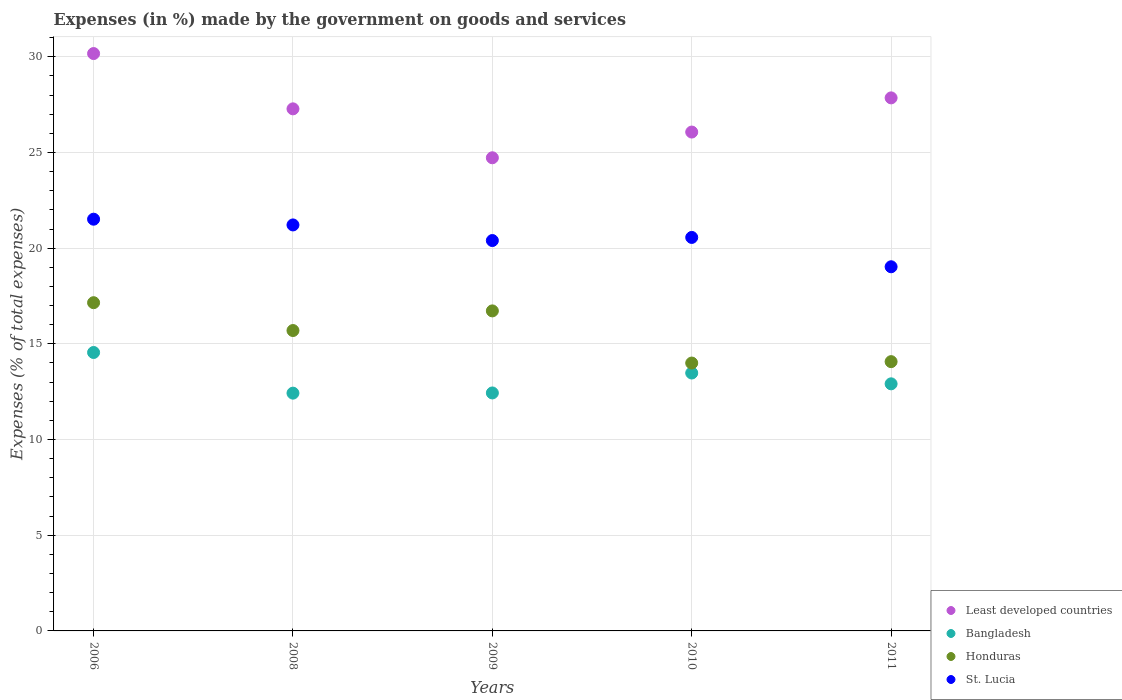What is the percentage of expenses made by the government on goods and services in Honduras in 2010?
Provide a succinct answer. 14. Across all years, what is the maximum percentage of expenses made by the government on goods and services in St. Lucia?
Ensure brevity in your answer.  21.51. Across all years, what is the minimum percentage of expenses made by the government on goods and services in Honduras?
Offer a terse response. 14. In which year was the percentage of expenses made by the government on goods and services in Honduras maximum?
Ensure brevity in your answer.  2006. What is the total percentage of expenses made by the government on goods and services in Least developed countries in the graph?
Your answer should be very brief. 136.1. What is the difference between the percentage of expenses made by the government on goods and services in Bangladesh in 2006 and that in 2011?
Offer a very short reply. 1.64. What is the difference between the percentage of expenses made by the government on goods and services in St. Lucia in 2006 and the percentage of expenses made by the government on goods and services in Least developed countries in 2010?
Offer a terse response. -4.55. What is the average percentage of expenses made by the government on goods and services in St. Lucia per year?
Your response must be concise. 20.54. In the year 2011, what is the difference between the percentage of expenses made by the government on goods and services in Honduras and percentage of expenses made by the government on goods and services in St. Lucia?
Give a very brief answer. -4.96. What is the ratio of the percentage of expenses made by the government on goods and services in Least developed countries in 2009 to that in 2010?
Your response must be concise. 0.95. Is the percentage of expenses made by the government on goods and services in Honduras in 2008 less than that in 2009?
Offer a terse response. Yes. Is the difference between the percentage of expenses made by the government on goods and services in Honduras in 2009 and 2010 greater than the difference between the percentage of expenses made by the government on goods and services in St. Lucia in 2009 and 2010?
Give a very brief answer. Yes. What is the difference between the highest and the second highest percentage of expenses made by the government on goods and services in Bangladesh?
Offer a terse response. 1.07. What is the difference between the highest and the lowest percentage of expenses made by the government on goods and services in Honduras?
Give a very brief answer. 3.15. Is the sum of the percentage of expenses made by the government on goods and services in Honduras in 2009 and 2010 greater than the maximum percentage of expenses made by the government on goods and services in Bangladesh across all years?
Give a very brief answer. Yes. Does the percentage of expenses made by the government on goods and services in Least developed countries monotonically increase over the years?
Provide a succinct answer. No. How many years are there in the graph?
Give a very brief answer. 5. Are the values on the major ticks of Y-axis written in scientific E-notation?
Provide a succinct answer. No. How many legend labels are there?
Give a very brief answer. 4. What is the title of the graph?
Your response must be concise. Expenses (in %) made by the government on goods and services. What is the label or title of the X-axis?
Your answer should be compact. Years. What is the label or title of the Y-axis?
Offer a very short reply. Expenses (% of total expenses). What is the Expenses (% of total expenses) in Least developed countries in 2006?
Your response must be concise. 30.17. What is the Expenses (% of total expenses) of Bangladesh in 2006?
Ensure brevity in your answer.  14.55. What is the Expenses (% of total expenses) in Honduras in 2006?
Your response must be concise. 17.15. What is the Expenses (% of total expenses) of St. Lucia in 2006?
Provide a succinct answer. 21.51. What is the Expenses (% of total expenses) of Least developed countries in 2008?
Your answer should be very brief. 27.28. What is the Expenses (% of total expenses) in Bangladesh in 2008?
Keep it short and to the point. 12.42. What is the Expenses (% of total expenses) in Honduras in 2008?
Provide a succinct answer. 15.7. What is the Expenses (% of total expenses) in St. Lucia in 2008?
Keep it short and to the point. 21.21. What is the Expenses (% of total expenses) of Least developed countries in 2009?
Ensure brevity in your answer.  24.72. What is the Expenses (% of total expenses) in Bangladesh in 2009?
Ensure brevity in your answer.  12.44. What is the Expenses (% of total expenses) in Honduras in 2009?
Make the answer very short. 16.72. What is the Expenses (% of total expenses) in St. Lucia in 2009?
Keep it short and to the point. 20.4. What is the Expenses (% of total expenses) of Least developed countries in 2010?
Make the answer very short. 26.07. What is the Expenses (% of total expenses) of Bangladesh in 2010?
Give a very brief answer. 13.48. What is the Expenses (% of total expenses) in Honduras in 2010?
Give a very brief answer. 14. What is the Expenses (% of total expenses) in St. Lucia in 2010?
Provide a short and direct response. 20.56. What is the Expenses (% of total expenses) in Least developed countries in 2011?
Your response must be concise. 27.85. What is the Expenses (% of total expenses) of Bangladesh in 2011?
Give a very brief answer. 12.91. What is the Expenses (% of total expenses) in Honduras in 2011?
Provide a succinct answer. 14.07. What is the Expenses (% of total expenses) of St. Lucia in 2011?
Your answer should be compact. 19.03. Across all years, what is the maximum Expenses (% of total expenses) of Least developed countries?
Make the answer very short. 30.17. Across all years, what is the maximum Expenses (% of total expenses) of Bangladesh?
Your answer should be very brief. 14.55. Across all years, what is the maximum Expenses (% of total expenses) in Honduras?
Provide a succinct answer. 17.15. Across all years, what is the maximum Expenses (% of total expenses) of St. Lucia?
Ensure brevity in your answer.  21.51. Across all years, what is the minimum Expenses (% of total expenses) of Least developed countries?
Make the answer very short. 24.72. Across all years, what is the minimum Expenses (% of total expenses) of Bangladesh?
Make the answer very short. 12.42. Across all years, what is the minimum Expenses (% of total expenses) of Honduras?
Your answer should be very brief. 14. Across all years, what is the minimum Expenses (% of total expenses) of St. Lucia?
Make the answer very short. 19.03. What is the total Expenses (% of total expenses) in Least developed countries in the graph?
Your answer should be compact. 136.1. What is the total Expenses (% of total expenses) of Bangladesh in the graph?
Keep it short and to the point. 65.8. What is the total Expenses (% of total expenses) of Honduras in the graph?
Offer a terse response. 77.64. What is the total Expenses (% of total expenses) of St. Lucia in the graph?
Keep it short and to the point. 102.72. What is the difference between the Expenses (% of total expenses) of Least developed countries in 2006 and that in 2008?
Keep it short and to the point. 2.89. What is the difference between the Expenses (% of total expenses) in Bangladesh in 2006 and that in 2008?
Your answer should be very brief. 2.12. What is the difference between the Expenses (% of total expenses) of Honduras in 2006 and that in 2008?
Your answer should be very brief. 1.45. What is the difference between the Expenses (% of total expenses) of St. Lucia in 2006 and that in 2008?
Your response must be concise. 0.3. What is the difference between the Expenses (% of total expenses) in Least developed countries in 2006 and that in 2009?
Ensure brevity in your answer.  5.45. What is the difference between the Expenses (% of total expenses) of Bangladesh in 2006 and that in 2009?
Your answer should be compact. 2.11. What is the difference between the Expenses (% of total expenses) in Honduras in 2006 and that in 2009?
Offer a very short reply. 0.43. What is the difference between the Expenses (% of total expenses) of St. Lucia in 2006 and that in 2009?
Offer a very short reply. 1.12. What is the difference between the Expenses (% of total expenses) of Least developed countries in 2006 and that in 2010?
Offer a very short reply. 4.1. What is the difference between the Expenses (% of total expenses) of Bangladesh in 2006 and that in 2010?
Provide a succinct answer. 1.07. What is the difference between the Expenses (% of total expenses) in Honduras in 2006 and that in 2010?
Your answer should be very brief. 3.15. What is the difference between the Expenses (% of total expenses) of St. Lucia in 2006 and that in 2010?
Keep it short and to the point. 0.95. What is the difference between the Expenses (% of total expenses) of Least developed countries in 2006 and that in 2011?
Your answer should be very brief. 2.32. What is the difference between the Expenses (% of total expenses) in Bangladesh in 2006 and that in 2011?
Make the answer very short. 1.64. What is the difference between the Expenses (% of total expenses) in Honduras in 2006 and that in 2011?
Your answer should be very brief. 3.08. What is the difference between the Expenses (% of total expenses) in St. Lucia in 2006 and that in 2011?
Provide a succinct answer. 2.49. What is the difference between the Expenses (% of total expenses) in Least developed countries in 2008 and that in 2009?
Your answer should be very brief. 2.56. What is the difference between the Expenses (% of total expenses) in Bangladesh in 2008 and that in 2009?
Offer a very short reply. -0.01. What is the difference between the Expenses (% of total expenses) of Honduras in 2008 and that in 2009?
Make the answer very short. -1.03. What is the difference between the Expenses (% of total expenses) of St. Lucia in 2008 and that in 2009?
Provide a succinct answer. 0.82. What is the difference between the Expenses (% of total expenses) in Least developed countries in 2008 and that in 2010?
Keep it short and to the point. 1.21. What is the difference between the Expenses (% of total expenses) in Bangladesh in 2008 and that in 2010?
Give a very brief answer. -1.05. What is the difference between the Expenses (% of total expenses) in Honduras in 2008 and that in 2010?
Offer a very short reply. 1.7. What is the difference between the Expenses (% of total expenses) in St. Lucia in 2008 and that in 2010?
Your response must be concise. 0.65. What is the difference between the Expenses (% of total expenses) of Least developed countries in 2008 and that in 2011?
Offer a terse response. -0.57. What is the difference between the Expenses (% of total expenses) of Bangladesh in 2008 and that in 2011?
Your answer should be compact. -0.49. What is the difference between the Expenses (% of total expenses) in Honduras in 2008 and that in 2011?
Give a very brief answer. 1.63. What is the difference between the Expenses (% of total expenses) in St. Lucia in 2008 and that in 2011?
Your answer should be very brief. 2.19. What is the difference between the Expenses (% of total expenses) in Least developed countries in 2009 and that in 2010?
Offer a terse response. -1.34. What is the difference between the Expenses (% of total expenses) in Bangladesh in 2009 and that in 2010?
Your answer should be very brief. -1.04. What is the difference between the Expenses (% of total expenses) in Honduras in 2009 and that in 2010?
Make the answer very short. 2.73. What is the difference between the Expenses (% of total expenses) in St. Lucia in 2009 and that in 2010?
Give a very brief answer. -0.16. What is the difference between the Expenses (% of total expenses) in Least developed countries in 2009 and that in 2011?
Ensure brevity in your answer.  -3.13. What is the difference between the Expenses (% of total expenses) in Bangladesh in 2009 and that in 2011?
Make the answer very short. -0.48. What is the difference between the Expenses (% of total expenses) of Honduras in 2009 and that in 2011?
Make the answer very short. 2.65. What is the difference between the Expenses (% of total expenses) of St. Lucia in 2009 and that in 2011?
Your answer should be very brief. 1.37. What is the difference between the Expenses (% of total expenses) in Least developed countries in 2010 and that in 2011?
Give a very brief answer. -1.79. What is the difference between the Expenses (% of total expenses) of Bangladesh in 2010 and that in 2011?
Your answer should be compact. 0.57. What is the difference between the Expenses (% of total expenses) of Honduras in 2010 and that in 2011?
Keep it short and to the point. -0.07. What is the difference between the Expenses (% of total expenses) in St. Lucia in 2010 and that in 2011?
Offer a very short reply. 1.53. What is the difference between the Expenses (% of total expenses) in Least developed countries in 2006 and the Expenses (% of total expenses) in Bangladesh in 2008?
Offer a terse response. 17.75. What is the difference between the Expenses (% of total expenses) of Least developed countries in 2006 and the Expenses (% of total expenses) of Honduras in 2008?
Provide a short and direct response. 14.47. What is the difference between the Expenses (% of total expenses) of Least developed countries in 2006 and the Expenses (% of total expenses) of St. Lucia in 2008?
Give a very brief answer. 8.96. What is the difference between the Expenses (% of total expenses) in Bangladesh in 2006 and the Expenses (% of total expenses) in Honduras in 2008?
Give a very brief answer. -1.15. What is the difference between the Expenses (% of total expenses) of Bangladesh in 2006 and the Expenses (% of total expenses) of St. Lucia in 2008?
Ensure brevity in your answer.  -6.67. What is the difference between the Expenses (% of total expenses) in Honduras in 2006 and the Expenses (% of total expenses) in St. Lucia in 2008?
Give a very brief answer. -4.06. What is the difference between the Expenses (% of total expenses) in Least developed countries in 2006 and the Expenses (% of total expenses) in Bangladesh in 2009?
Make the answer very short. 17.73. What is the difference between the Expenses (% of total expenses) of Least developed countries in 2006 and the Expenses (% of total expenses) of Honduras in 2009?
Your answer should be compact. 13.45. What is the difference between the Expenses (% of total expenses) of Least developed countries in 2006 and the Expenses (% of total expenses) of St. Lucia in 2009?
Offer a terse response. 9.77. What is the difference between the Expenses (% of total expenses) in Bangladesh in 2006 and the Expenses (% of total expenses) in Honduras in 2009?
Give a very brief answer. -2.17. What is the difference between the Expenses (% of total expenses) in Bangladesh in 2006 and the Expenses (% of total expenses) in St. Lucia in 2009?
Offer a very short reply. -5.85. What is the difference between the Expenses (% of total expenses) of Honduras in 2006 and the Expenses (% of total expenses) of St. Lucia in 2009?
Ensure brevity in your answer.  -3.25. What is the difference between the Expenses (% of total expenses) of Least developed countries in 2006 and the Expenses (% of total expenses) of Bangladesh in 2010?
Give a very brief answer. 16.69. What is the difference between the Expenses (% of total expenses) in Least developed countries in 2006 and the Expenses (% of total expenses) in Honduras in 2010?
Offer a terse response. 16.17. What is the difference between the Expenses (% of total expenses) in Least developed countries in 2006 and the Expenses (% of total expenses) in St. Lucia in 2010?
Give a very brief answer. 9.61. What is the difference between the Expenses (% of total expenses) of Bangladesh in 2006 and the Expenses (% of total expenses) of Honduras in 2010?
Keep it short and to the point. 0.55. What is the difference between the Expenses (% of total expenses) in Bangladesh in 2006 and the Expenses (% of total expenses) in St. Lucia in 2010?
Provide a short and direct response. -6.01. What is the difference between the Expenses (% of total expenses) of Honduras in 2006 and the Expenses (% of total expenses) of St. Lucia in 2010?
Your answer should be compact. -3.41. What is the difference between the Expenses (% of total expenses) in Least developed countries in 2006 and the Expenses (% of total expenses) in Bangladesh in 2011?
Your response must be concise. 17.26. What is the difference between the Expenses (% of total expenses) in Least developed countries in 2006 and the Expenses (% of total expenses) in Honduras in 2011?
Ensure brevity in your answer.  16.1. What is the difference between the Expenses (% of total expenses) of Least developed countries in 2006 and the Expenses (% of total expenses) of St. Lucia in 2011?
Give a very brief answer. 11.14. What is the difference between the Expenses (% of total expenses) in Bangladesh in 2006 and the Expenses (% of total expenses) in Honduras in 2011?
Your answer should be very brief. 0.48. What is the difference between the Expenses (% of total expenses) of Bangladesh in 2006 and the Expenses (% of total expenses) of St. Lucia in 2011?
Offer a very short reply. -4.48. What is the difference between the Expenses (% of total expenses) in Honduras in 2006 and the Expenses (% of total expenses) in St. Lucia in 2011?
Keep it short and to the point. -1.88. What is the difference between the Expenses (% of total expenses) in Least developed countries in 2008 and the Expenses (% of total expenses) in Bangladesh in 2009?
Your response must be concise. 14.85. What is the difference between the Expenses (% of total expenses) in Least developed countries in 2008 and the Expenses (% of total expenses) in Honduras in 2009?
Give a very brief answer. 10.56. What is the difference between the Expenses (% of total expenses) in Least developed countries in 2008 and the Expenses (% of total expenses) in St. Lucia in 2009?
Offer a very short reply. 6.88. What is the difference between the Expenses (% of total expenses) in Bangladesh in 2008 and the Expenses (% of total expenses) in Honduras in 2009?
Offer a very short reply. -4.3. What is the difference between the Expenses (% of total expenses) in Bangladesh in 2008 and the Expenses (% of total expenses) in St. Lucia in 2009?
Offer a very short reply. -7.97. What is the difference between the Expenses (% of total expenses) of Honduras in 2008 and the Expenses (% of total expenses) of St. Lucia in 2009?
Ensure brevity in your answer.  -4.7. What is the difference between the Expenses (% of total expenses) of Least developed countries in 2008 and the Expenses (% of total expenses) of Bangladesh in 2010?
Your response must be concise. 13.8. What is the difference between the Expenses (% of total expenses) in Least developed countries in 2008 and the Expenses (% of total expenses) in Honduras in 2010?
Your answer should be very brief. 13.28. What is the difference between the Expenses (% of total expenses) in Least developed countries in 2008 and the Expenses (% of total expenses) in St. Lucia in 2010?
Provide a succinct answer. 6.72. What is the difference between the Expenses (% of total expenses) of Bangladesh in 2008 and the Expenses (% of total expenses) of Honduras in 2010?
Provide a succinct answer. -1.57. What is the difference between the Expenses (% of total expenses) of Bangladesh in 2008 and the Expenses (% of total expenses) of St. Lucia in 2010?
Keep it short and to the point. -8.14. What is the difference between the Expenses (% of total expenses) of Honduras in 2008 and the Expenses (% of total expenses) of St. Lucia in 2010?
Your answer should be compact. -4.86. What is the difference between the Expenses (% of total expenses) in Least developed countries in 2008 and the Expenses (% of total expenses) in Bangladesh in 2011?
Your response must be concise. 14.37. What is the difference between the Expenses (% of total expenses) in Least developed countries in 2008 and the Expenses (% of total expenses) in Honduras in 2011?
Your answer should be very brief. 13.21. What is the difference between the Expenses (% of total expenses) in Least developed countries in 2008 and the Expenses (% of total expenses) in St. Lucia in 2011?
Offer a very short reply. 8.25. What is the difference between the Expenses (% of total expenses) in Bangladesh in 2008 and the Expenses (% of total expenses) in Honduras in 2011?
Make the answer very short. -1.65. What is the difference between the Expenses (% of total expenses) in Bangladesh in 2008 and the Expenses (% of total expenses) in St. Lucia in 2011?
Give a very brief answer. -6.6. What is the difference between the Expenses (% of total expenses) in Honduras in 2008 and the Expenses (% of total expenses) in St. Lucia in 2011?
Make the answer very short. -3.33. What is the difference between the Expenses (% of total expenses) in Least developed countries in 2009 and the Expenses (% of total expenses) in Bangladesh in 2010?
Provide a short and direct response. 11.25. What is the difference between the Expenses (% of total expenses) of Least developed countries in 2009 and the Expenses (% of total expenses) of Honduras in 2010?
Ensure brevity in your answer.  10.73. What is the difference between the Expenses (% of total expenses) in Least developed countries in 2009 and the Expenses (% of total expenses) in St. Lucia in 2010?
Make the answer very short. 4.16. What is the difference between the Expenses (% of total expenses) of Bangladesh in 2009 and the Expenses (% of total expenses) of Honduras in 2010?
Give a very brief answer. -1.56. What is the difference between the Expenses (% of total expenses) in Bangladesh in 2009 and the Expenses (% of total expenses) in St. Lucia in 2010?
Your answer should be very brief. -8.13. What is the difference between the Expenses (% of total expenses) in Honduras in 2009 and the Expenses (% of total expenses) in St. Lucia in 2010?
Your answer should be very brief. -3.84. What is the difference between the Expenses (% of total expenses) in Least developed countries in 2009 and the Expenses (% of total expenses) in Bangladesh in 2011?
Offer a very short reply. 11.81. What is the difference between the Expenses (% of total expenses) of Least developed countries in 2009 and the Expenses (% of total expenses) of Honduras in 2011?
Ensure brevity in your answer.  10.65. What is the difference between the Expenses (% of total expenses) in Least developed countries in 2009 and the Expenses (% of total expenses) in St. Lucia in 2011?
Give a very brief answer. 5.7. What is the difference between the Expenses (% of total expenses) of Bangladesh in 2009 and the Expenses (% of total expenses) of Honduras in 2011?
Give a very brief answer. -1.64. What is the difference between the Expenses (% of total expenses) in Bangladesh in 2009 and the Expenses (% of total expenses) in St. Lucia in 2011?
Your answer should be very brief. -6.59. What is the difference between the Expenses (% of total expenses) in Honduras in 2009 and the Expenses (% of total expenses) in St. Lucia in 2011?
Your response must be concise. -2.31. What is the difference between the Expenses (% of total expenses) in Least developed countries in 2010 and the Expenses (% of total expenses) in Bangladesh in 2011?
Keep it short and to the point. 13.16. What is the difference between the Expenses (% of total expenses) in Least developed countries in 2010 and the Expenses (% of total expenses) in Honduras in 2011?
Keep it short and to the point. 12. What is the difference between the Expenses (% of total expenses) in Least developed countries in 2010 and the Expenses (% of total expenses) in St. Lucia in 2011?
Make the answer very short. 7.04. What is the difference between the Expenses (% of total expenses) of Bangladesh in 2010 and the Expenses (% of total expenses) of Honduras in 2011?
Offer a very short reply. -0.59. What is the difference between the Expenses (% of total expenses) in Bangladesh in 2010 and the Expenses (% of total expenses) in St. Lucia in 2011?
Give a very brief answer. -5.55. What is the difference between the Expenses (% of total expenses) in Honduras in 2010 and the Expenses (% of total expenses) in St. Lucia in 2011?
Offer a very short reply. -5.03. What is the average Expenses (% of total expenses) in Least developed countries per year?
Offer a terse response. 27.22. What is the average Expenses (% of total expenses) of Bangladesh per year?
Provide a short and direct response. 13.16. What is the average Expenses (% of total expenses) of Honduras per year?
Your answer should be compact. 15.53. What is the average Expenses (% of total expenses) in St. Lucia per year?
Offer a terse response. 20.54. In the year 2006, what is the difference between the Expenses (% of total expenses) of Least developed countries and Expenses (% of total expenses) of Bangladesh?
Offer a terse response. 15.62. In the year 2006, what is the difference between the Expenses (% of total expenses) of Least developed countries and Expenses (% of total expenses) of Honduras?
Ensure brevity in your answer.  13.02. In the year 2006, what is the difference between the Expenses (% of total expenses) in Least developed countries and Expenses (% of total expenses) in St. Lucia?
Your answer should be compact. 8.66. In the year 2006, what is the difference between the Expenses (% of total expenses) of Bangladesh and Expenses (% of total expenses) of Honduras?
Give a very brief answer. -2.6. In the year 2006, what is the difference between the Expenses (% of total expenses) in Bangladesh and Expenses (% of total expenses) in St. Lucia?
Offer a very short reply. -6.96. In the year 2006, what is the difference between the Expenses (% of total expenses) in Honduras and Expenses (% of total expenses) in St. Lucia?
Offer a terse response. -4.36. In the year 2008, what is the difference between the Expenses (% of total expenses) in Least developed countries and Expenses (% of total expenses) in Bangladesh?
Make the answer very short. 14.86. In the year 2008, what is the difference between the Expenses (% of total expenses) of Least developed countries and Expenses (% of total expenses) of Honduras?
Make the answer very short. 11.58. In the year 2008, what is the difference between the Expenses (% of total expenses) in Least developed countries and Expenses (% of total expenses) in St. Lucia?
Your answer should be very brief. 6.07. In the year 2008, what is the difference between the Expenses (% of total expenses) in Bangladesh and Expenses (% of total expenses) in Honduras?
Keep it short and to the point. -3.27. In the year 2008, what is the difference between the Expenses (% of total expenses) of Bangladesh and Expenses (% of total expenses) of St. Lucia?
Make the answer very short. -8.79. In the year 2008, what is the difference between the Expenses (% of total expenses) in Honduras and Expenses (% of total expenses) in St. Lucia?
Provide a short and direct response. -5.52. In the year 2009, what is the difference between the Expenses (% of total expenses) in Least developed countries and Expenses (% of total expenses) in Bangladesh?
Offer a very short reply. 12.29. In the year 2009, what is the difference between the Expenses (% of total expenses) of Least developed countries and Expenses (% of total expenses) of Honduras?
Provide a short and direct response. 8. In the year 2009, what is the difference between the Expenses (% of total expenses) in Least developed countries and Expenses (% of total expenses) in St. Lucia?
Keep it short and to the point. 4.32. In the year 2009, what is the difference between the Expenses (% of total expenses) in Bangladesh and Expenses (% of total expenses) in Honduras?
Your answer should be compact. -4.29. In the year 2009, what is the difference between the Expenses (% of total expenses) in Bangladesh and Expenses (% of total expenses) in St. Lucia?
Give a very brief answer. -7.96. In the year 2009, what is the difference between the Expenses (% of total expenses) of Honduras and Expenses (% of total expenses) of St. Lucia?
Provide a succinct answer. -3.68. In the year 2010, what is the difference between the Expenses (% of total expenses) of Least developed countries and Expenses (% of total expenses) of Bangladesh?
Offer a very short reply. 12.59. In the year 2010, what is the difference between the Expenses (% of total expenses) in Least developed countries and Expenses (% of total expenses) in Honduras?
Your response must be concise. 12.07. In the year 2010, what is the difference between the Expenses (% of total expenses) of Least developed countries and Expenses (% of total expenses) of St. Lucia?
Your answer should be compact. 5.51. In the year 2010, what is the difference between the Expenses (% of total expenses) of Bangladesh and Expenses (% of total expenses) of Honduras?
Give a very brief answer. -0.52. In the year 2010, what is the difference between the Expenses (% of total expenses) in Bangladesh and Expenses (% of total expenses) in St. Lucia?
Your response must be concise. -7.08. In the year 2010, what is the difference between the Expenses (% of total expenses) of Honduras and Expenses (% of total expenses) of St. Lucia?
Ensure brevity in your answer.  -6.56. In the year 2011, what is the difference between the Expenses (% of total expenses) of Least developed countries and Expenses (% of total expenses) of Bangladesh?
Your answer should be compact. 14.94. In the year 2011, what is the difference between the Expenses (% of total expenses) of Least developed countries and Expenses (% of total expenses) of Honduras?
Keep it short and to the point. 13.78. In the year 2011, what is the difference between the Expenses (% of total expenses) in Least developed countries and Expenses (% of total expenses) in St. Lucia?
Your answer should be very brief. 8.83. In the year 2011, what is the difference between the Expenses (% of total expenses) of Bangladesh and Expenses (% of total expenses) of Honduras?
Make the answer very short. -1.16. In the year 2011, what is the difference between the Expenses (% of total expenses) in Bangladesh and Expenses (% of total expenses) in St. Lucia?
Ensure brevity in your answer.  -6.12. In the year 2011, what is the difference between the Expenses (% of total expenses) in Honduras and Expenses (% of total expenses) in St. Lucia?
Your answer should be very brief. -4.96. What is the ratio of the Expenses (% of total expenses) in Least developed countries in 2006 to that in 2008?
Make the answer very short. 1.11. What is the ratio of the Expenses (% of total expenses) in Bangladesh in 2006 to that in 2008?
Ensure brevity in your answer.  1.17. What is the ratio of the Expenses (% of total expenses) of Honduras in 2006 to that in 2008?
Ensure brevity in your answer.  1.09. What is the ratio of the Expenses (% of total expenses) of St. Lucia in 2006 to that in 2008?
Make the answer very short. 1.01. What is the ratio of the Expenses (% of total expenses) of Least developed countries in 2006 to that in 2009?
Your answer should be compact. 1.22. What is the ratio of the Expenses (% of total expenses) of Bangladesh in 2006 to that in 2009?
Your response must be concise. 1.17. What is the ratio of the Expenses (% of total expenses) in Honduras in 2006 to that in 2009?
Give a very brief answer. 1.03. What is the ratio of the Expenses (% of total expenses) in St. Lucia in 2006 to that in 2009?
Provide a succinct answer. 1.05. What is the ratio of the Expenses (% of total expenses) of Least developed countries in 2006 to that in 2010?
Offer a very short reply. 1.16. What is the ratio of the Expenses (% of total expenses) in Bangladesh in 2006 to that in 2010?
Offer a terse response. 1.08. What is the ratio of the Expenses (% of total expenses) in Honduras in 2006 to that in 2010?
Your response must be concise. 1.23. What is the ratio of the Expenses (% of total expenses) of St. Lucia in 2006 to that in 2010?
Provide a succinct answer. 1.05. What is the ratio of the Expenses (% of total expenses) of Least developed countries in 2006 to that in 2011?
Keep it short and to the point. 1.08. What is the ratio of the Expenses (% of total expenses) of Bangladesh in 2006 to that in 2011?
Your answer should be very brief. 1.13. What is the ratio of the Expenses (% of total expenses) in Honduras in 2006 to that in 2011?
Your answer should be very brief. 1.22. What is the ratio of the Expenses (% of total expenses) in St. Lucia in 2006 to that in 2011?
Your response must be concise. 1.13. What is the ratio of the Expenses (% of total expenses) in Least developed countries in 2008 to that in 2009?
Provide a succinct answer. 1.1. What is the ratio of the Expenses (% of total expenses) in Bangladesh in 2008 to that in 2009?
Make the answer very short. 1. What is the ratio of the Expenses (% of total expenses) of Honduras in 2008 to that in 2009?
Offer a very short reply. 0.94. What is the ratio of the Expenses (% of total expenses) in Least developed countries in 2008 to that in 2010?
Your answer should be compact. 1.05. What is the ratio of the Expenses (% of total expenses) of Bangladesh in 2008 to that in 2010?
Offer a terse response. 0.92. What is the ratio of the Expenses (% of total expenses) in Honduras in 2008 to that in 2010?
Give a very brief answer. 1.12. What is the ratio of the Expenses (% of total expenses) of St. Lucia in 2008 to that in 2010?
Make the answer very short. 1.03. What is the ratio of the Expenses (% of total expenses) in Least developed countries in 2008 to that in 2011?
Your answer should be very brief. 0.98. What is the ratio of the Expenses (% of total expenses) of Bangladesh in 2008 to that in 2011?
Offer a terse response. 0.96. What is the ratio of the Expenses (% of total expenses) in Honduras in 2008 to that in 2011?
Your answer should be very brief. 1.12. What is the ratio of the Expenses (% of total expenses) in St. Lucia in 2008 to that in 2011?
Offer a very short reply. 1.11. What is the ratio of the Expenses (% of total expenses) in Least developed countries in 2009 to that in 2010?
Your response must be concise. 0.95. What is the ratio of the Expenses (% of total expenses) in Bangladesh in 2009 to that in 2010?
Offer a very short reply. 0.92. What is the ratio of the Expenses (% of total expenses) in Honduras in 2009 to that in 2010?
Your answer should be compact. 1.19. What is the ratio of the Expenses (% of total expenses) in Least developed countries in 2009 to that in 2011?
Make the answer very short. 0.89. What is the ratio of the Expenses (% of total expenses) of Bangladesh in 2009 to that in 2011?
Provide a succinct answer. 0.96. What is the ratio of the Expenses (% of total expenses) in Honduras in 2009 to that in 2011?
Offer a very short reply. 1.19. What is the ratio of the Expenses (% of total expenses) of St. Lucia in 2009 to that in 2011?
Your answer should be compact. 1.07. What is the ratio of the Expenses (% of total expenses) in Least developed countries in 2010 to that in 2011?
Make the answer very short. 0.94. What is the ratio of the Expenses (% of total expenses) of Bangladesh in 2010 to that in 2011?
Offer a very short reply. 1.04. What is the ratio of the Expenses (% of total expenses) in St. Lucia in 2010 to that in 2011?
Offer a very short reply. 1.08. What is the difference between the highest and the second highest Expenses (% of total expenses) of Least developed countries?
Provide a succinct answer. 2.32. What is the difference between the highest and the second highest Expenses (% of total expenses) in Bangladesh?
Your response must be concise. 1.07. What is the difference between the highest and the second highest Expenses (% of total expenses) of Honduras?
Make the answer very short. 0.43. What is the difference between the highest and the second highest Expenses (% of total expenses) in St. Lucia?
Make the answer very short. 0.3. What is the difference between the highest and the lowest Expenses (% of total expenses) of Least developed countries?
Make the answer very short. 5.45. What is the difference between the highest and the lowest Expenses (% of total expenses) in Bangladesh?
Give a very brief answer. 2.12. What is the difference between the highest and the lowest Expenses (% of total expenses) of Honduras?
Offer a very short reply. 3.15. What is the difference between the highest and the lowest Expenses (% of total expenses) of St. Lucia?
Provide a short and direct response. 2.49. 